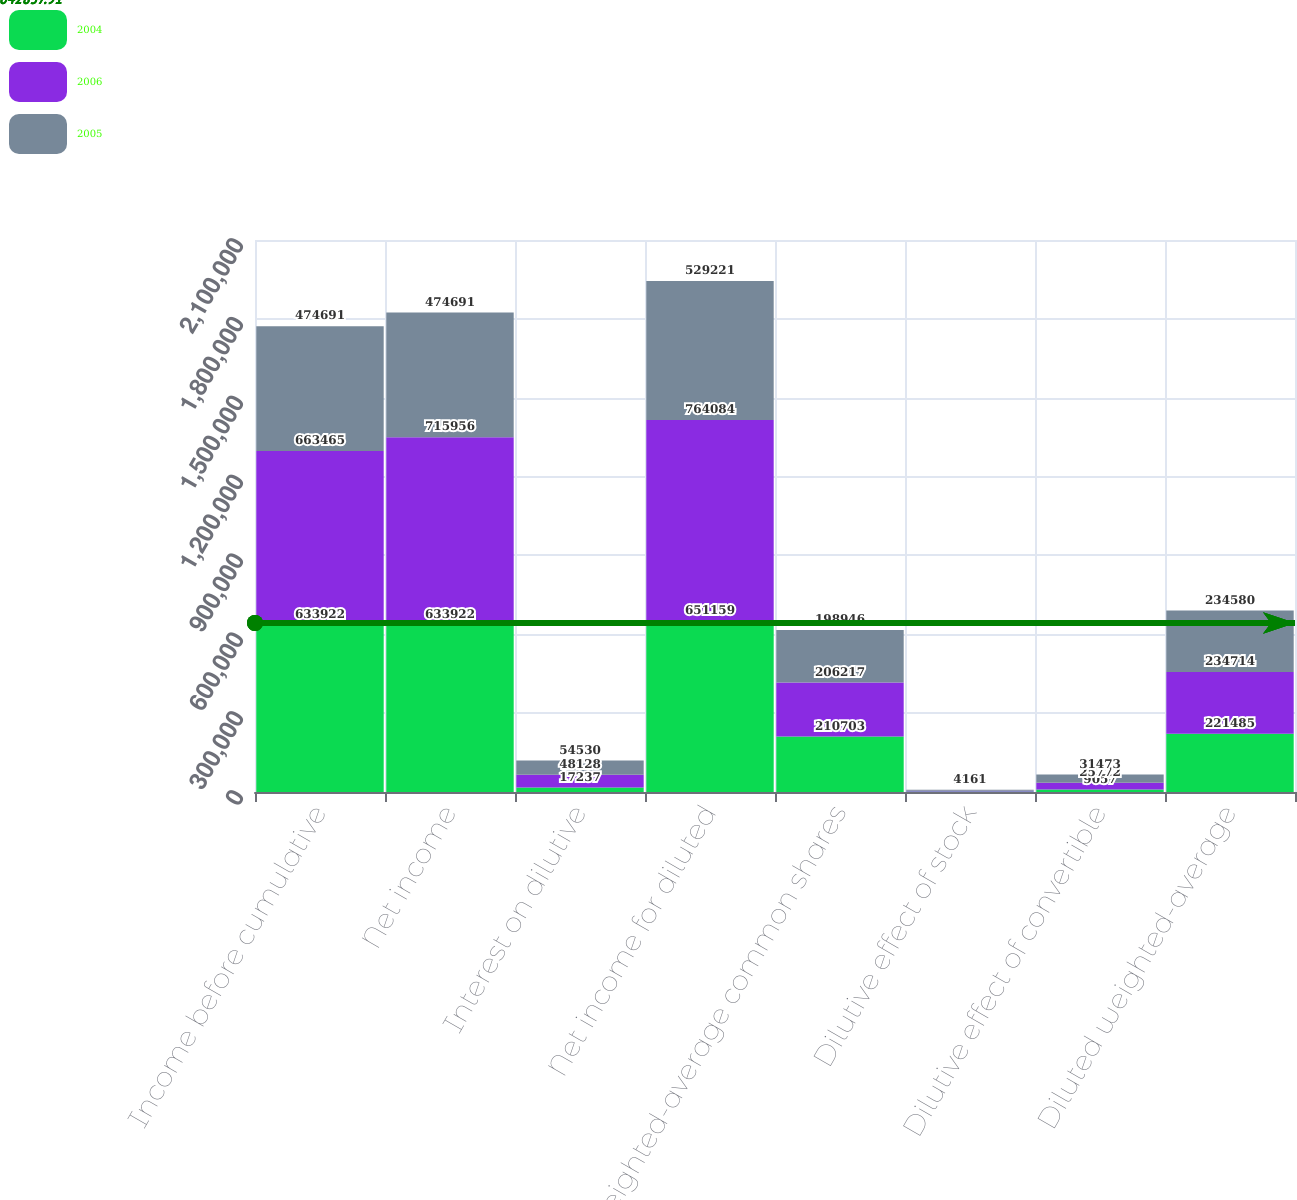<chart> <loc_0><loc_0><loc_500><loc_500><stacked_bar_chart><ecel><fcel>Income before cumulative<fcel>Net income<fcel>Interest on dilutive<fcel>Net income for diluted<fcel>Weighted-average common shares<fcel>Dilutive effect of stock<fcel>Dilutive effect of convertible<fcel>Diluted weighted-average<nl><fcel>2004<fcel>633922<fcel>633922<fcel>17237<fcel>651159<fcel>210703<fcel>1725<fcel>9057<fcel>221485<nl><fcel>2006<fcel>663465<fcel>715956<fcel>48128<fcel>764084<fcel>206217<fcel>2725<fcel>25772<fcel>234714<nl><fcel>2005<fcel>474691<fcel>474691<fcel>54530<fcel>529221<fcel>198946<fcel>4161<fcel>31473<fcel>234580<nl></chart> 